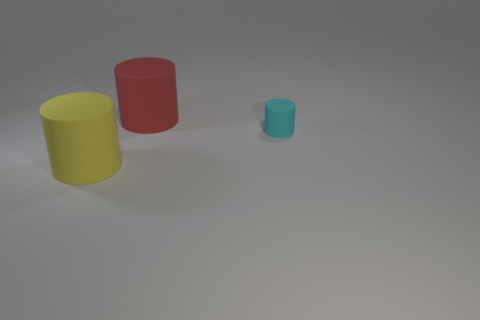Subtract all large cylinders. How many cylinders are left? 1 Add 3 big matte things. How many objects exist? 6 Subtract all brown cylinders. Subtract all cyan cubes. How many cylinders are left? 3 Add 1 large red rubber cylinders. How many large red rubber cylinders exist? 2 Subtract 0 blue blocks. How many objects are left? 3 Subtract all big matte things. Subtract all tiny gray rubber things. How many objects are left? 1 Add 2 red cylinders. How many red cylinders are left? 3 